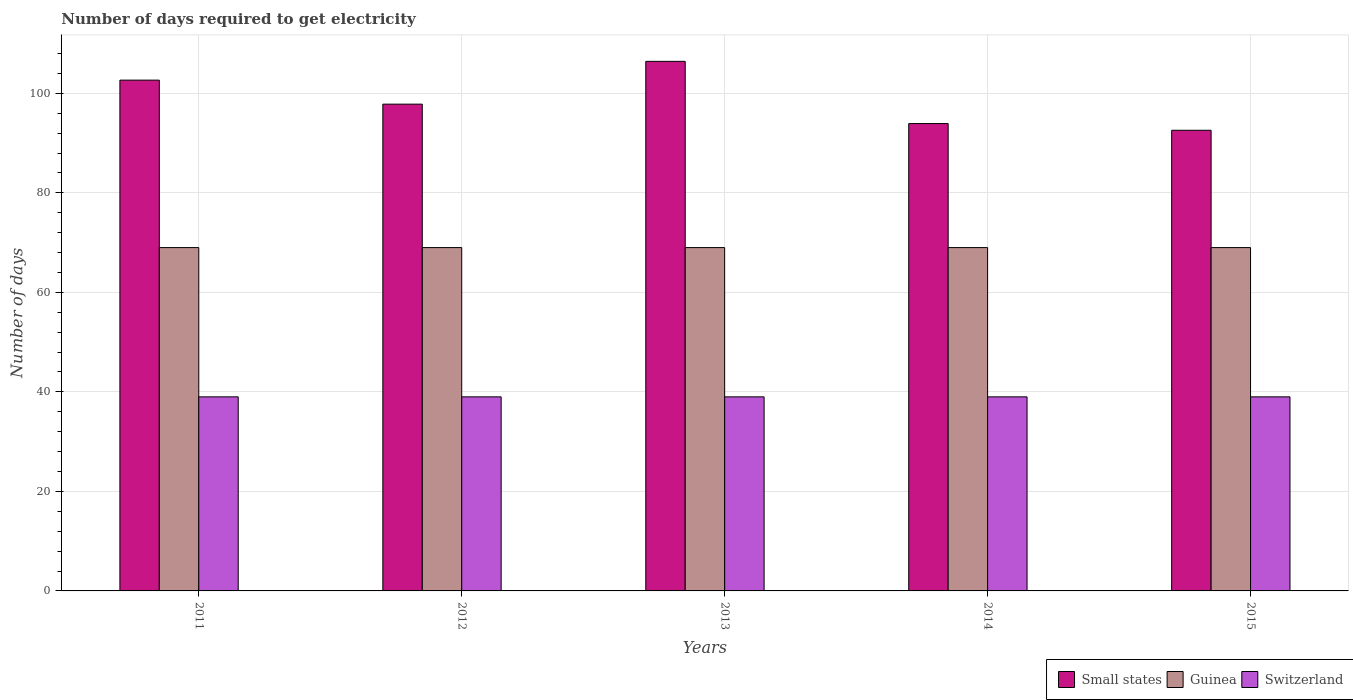How many groups of bars are there?
Your response must be concise. 5. Are the number of bars on each tick of the X-axis equal?
Offer a terse response. Yes. How many bars are there on the 2nd tick from the left?
Offer a very short reply. 3. How many bars are there on the 4th tick from the right?
Give a very brief answer. 3. In how many cases, is the number of bars for a given year not equal to the number of legend labels?
Your response must be concise. 0. What is the number of days required to get electricity in in Switzerland in 2014?
Keep it short and to the point. 39. Across all years, what is the maximum number of days required to get electricity in in Switzerland?
Your response must be concise. 39. Across all years, what is the minimum number of days required to get electricity in in Small states?
Make the answer very short. 92.58. In which year was the number of days required to get electricity in in Guinea minimum?
Make the answer very short. 2011. What is the total number of days required to get electricity in in Switzerland in the graph?
Ensure brevity in your answer.  195. What is the difference between the number of days required to get electricity in in Small states in 2011 and that in 2014?
Provide a short and direct response. 8.73. What is the difference between the number of days required to get electricity in in Small states in 2014 and the number of days required to get electricity in in Switzerland in 2012?
Your response must be concise. 54.92. What is the average number of days required to get electricity in in Small states per year?
Offer a terse response. 98.68. In the year 2014, what is the difference between the number of days required to get electricity in in Guinea and number of days required to get electricity in in Small states?
Your answer should be very brief. -24.92. In how many years, is the number of days required to get electricity in in Small states greater than 44 days?
Give a very brief answer. 5. Is the number of days required to get electricity in in Small states in 2011 less than that in 2015?
Ensure brevity in your answer.  No. What is the difference between the highest and the second highest number of days required to get electricity in in Guinea?
Provide a short and direct response. 0. What is the difference between the highest and the lowest number of days required to get electricity in in Switzerland?
Give a very brief answer. 0. What does the 2nd bar from the left in 2012 represents?
Make the answer very short. Guinea. What does the 2nd bar from the right in 2012 represents?
Offer a terse response. Guinea. Where does the legend appear in the graph?
Ensure brevity in your answer.  Bottom right. How many legend labels are there?
Make the answer very short. 3. How are the legend labels stacked?
Provide a succinct answer. Horizontal. What is the title of the graph?
Ensure brevity in your answer.  Number of days required to get electricity. What is the label or title of the X-axis?
Provide a succinct answer. Years. What is the label or title of the Y-axis?
Ensure brevity in your answer.  Number of days. What is the Number of days of Small states in 2011?
Your answer should be very brief. 102.65. What is the Number of days in Guinea in 2011?
Your answer should be very brief. 69. What is the Number of days of Switzerland in 2011?
Offer a terse response. 39. What is the Number of days of Small states in 2012?
Your answer should be very brief. 97.83. What is the Number of days in Guinea in 2012?
Your answer should be very brief. 69. What is the Number of days in Small states in 2013?
Offer a terse response. 106.42. What is the Number of days of Switzerland in 2013?
Provide a short and direct response. 39. What is the Number of days of Small states in 2014?
Offer a very short reply. 93.92. What is the Number of days of Switzerland in 2014?
Give a very brief answer. 39. What is the Number of days of Small states in 2015?
Your answer should be very brief. 92.58. What is the Number of days in Switzerland in 2015?
Make the answer very short. 39. Across all years, what is the maximum Number of days of Small states?
Ensure brevity in your answer.  106.42. Across all years, what is the maximum Number of days in Switzerland?
Offer a very short reply. 39. Across all years, what is the minimum Number of days in Small states?
Ensure brevity in your answer.  92.58. Across all years, what is the minimum Number of days of Guinea?
Provide a succinct answer. 69. Across all years, what is the minimum Number of days of Switzerland?
Your answer should be compact. 39. What is the total Number of days of Small states in the graph?
Your response must be concise. 493.4. What is the total Number of days of Guinea in the graph?
Offer a very short reply. 345. What is the total Number of days in Switzerland in the graph?
Provide a short and direct response. 195. What is the difference between the Number of days of Small states in 2011 and that in 2012?
Your response must be concise. 4.83. What is the difference between the Number of days in Small states in 2011 and that in 2013?
Give a very brief answer. -3.77. What is the difference between the Number of days in Guinea in 2011 and that in 2013?
Your answer should be very brief. 0. What is the difference between the Number of days in Switzerland in 2011 and that in 2013?
Provide a short and direct response. 0. What is the difference between the Number of days in Small states in 2011 and that in 2014?
Give a very brief answer. 8.72. What is the difference between the Number of days in Small states in 2011 and that in 2015?
Keep it short and to the point. 10.07. What is the difference between the Number of days of Switzerland in 2011 and that in 2015?
Give a very brief answer. 0. What is the difference between the Number of days of Small states in 2012 and that in 2013?
Your answer should be very brief. -8.6. What is the difference between the Number of days of Guinea in 2012 and that in 2013?
Your answer should be very brief. 0. What is the difference between the Number of days of Small states in 2012 and that in 2015?
Offer a terse response. 5.25. What is the difference between the Number of days of Small states in 2013 and that in 2014?
Offer a very short reply. 12.5. What is the difference between the Number of days in Guinea in 2013 and that in 2014?
Make the answer very short. 0. What is the difference between the Number of days of Small states in 2013 and that in 2015?
Provide a succinct answer. 13.85. What is the difference between the Number of days in Guinea in 2013 and that in 2015?
Offer a very short reply. 0. What is the difference between the Number of days in Switzerland in 2013 and that in 2015?
Offer a very short reply. 0. What is the difference between the Number of days in Small states in 2014 and that in 2015?
Keep it short and to the point. 1.35. What is the difference between the Number of days in Switzerland in 2014 and that in 2015?
Provide a short and direct response. 0. What is the difference between the Number of days of Small states in 2011 and the Number of days of Guinea in 2012?
Keep it short and to the point. 33.65. What is the difference between the Number of days in Small states in 2011 and the Number of days in Switzerland in 2012?
Provide a succinct answer. 63.65. What is the difference between the Number of days in Small states in 2011 and the Number of days in Guinea in 2013?
Provide a succinct answer. 33.65. What is the difference between the Number of days in Small states in 2011 and the Number of days in Switzerland in 2013?
Your answer should be very brief. 63.65. What is the difference between the Number of days in Guinea in 2011 and the Number of days in Switzerland in 2013?
Keep it short and to the point. 30. What is the difference between the Number of days of Small states in 2011 and the Number of days of Guinea in 2014?
Your response must be concise. 33.65. What is the difference between the Number of days of Small states in 2011 and the Number of days of Switzerland in 2014?
Provide a short and direct response. 63.65. What is the difference between the Number of days of Small states in 2011 and the Number of days of Guinea in 2015?
Provide a succinct answer. 33.65. What is the difference between the Number of days in Small states in 2011 and the Number of days in Switzerland in 2015?
Provide a succinct answer. 63.65. What is the difference between the Number of days in Guinea in 2011 and the Number of days in Switzerland in 2015?
Offer a terse response. 30. What is the difference between the Number of days in Small states in 2012 and the Number of days in Guinea in 2013?
Provide a succinct answer. 28.82. What is the difference between the Number of days in Small states in 2012 and the Number of days in Switzerland in 2013?
Ensure brevity in your answer.  58.83. What is the difference between the Number of days of Small states in 2012 and the Number of days of Guinea in 2014?
Provide a succinct answer. 28.82. What is the difference between the Number of days of Small states in 2012 and the Number of days of Switzerland in 2014?
Your answer should be very brief. 58.83. What is the difference between the Number of days in Small states in 2012 and the Number of days in Guinea in 2015?
Ensure brevity in your answer.  28.82. What is the difference between the Number of days in Small states in 2012 and the Number of days in Switzerland in 2015?
Ensure brevity in your answer.  58.83. What is the difference between the Number of days of Guinea in 2012 and the Number of days of Switzerland in 2015?
Offer a very short reply. 30. What is the difference between the Number of days in Small states in 2013 and the Number of days in Guinea in 2014?
Offer a very short reply. 37.42. What is the difference between the Number of days in Small states in 2013 and the Number of days in Switzerland in 2014?
Provide a short and direct response. 67.42. What is the difference between the Number of days in Guinea in 2013 and the Number of days in Switzerland in 2014?
Offer a terse response. 30. What is the difference between the Number of days of Small states in 2013 and the Number of days of Guinea in 2015?
Offer a very short reply. 37.42. What is the difference between the Number of days of Small states in 2013 and the Number of days of Switzerland in 2015?
Offer a terse response. 67.42. What is the difference between the Number of days of Guinea in 2013 and the Number of days of Switzerland in 2015?
Offer a terse response. 30. What is the difference between the Number of days of Small states in 2014 and the Number of days of Guinea in 2015?
Keep it short and to the point. 24.93. What is the difference between the Number of days in Small states in 2014 and the Number of days in Switzerland in 2015?
Your answer should be very brief. 54.92. What is the difference between the Number of days of Guinea in 2014 and the Number of days of Switzerland in 2015?
Keep it short and to the point. 30. What is the average Number of days of Small states per year?
Offer a very short reply. 98.68. What is the average Number of days in Switzerland per year?
Offer a terse response. 39. In the year 2011, what is the difference between the Number of days of Small states and Number of days of Guinea?
Make the answer very short. 33.65. In the year 2011, what is the difference between the Number of days of Small states and Number of days of Switzerland?
Provide a short and direct response. 63.65. In the year 2012, what is the difference between the Number of days of Small states and Number of days of Guinea?
Ensure brevity in your answer.  28.82. In the year 2012, what is the difference between the Number of days in Small states and Number of days in Switzerland?
Offer a terse response. 58.83. In the year 2013, what is the difference between the Number of days in Small states and Number of days in Guinea?
Offer a terse response. 37.42. In the year 2013, what is the difference between the Number of days in Small states and Number of days in Switzerland?
Offer a very short reply. 67.42. In the year 2014, what is the difference between the Number of days in Small states and Number of days in Guinea?
Ensure brevity in your answer.  24.93. In the year 2014, what is the difference between the Number of days of Small states and Number of days of Switzerland?
Ensure brevity in your answer.  54.92. In the year 2015, what is the difference between the Number of days in Small states and Number of days in Guinea?
Give a very brief answer. 23.57. In the year 2015, what is the difference between the Number of days of Small states and Number of days of Switzerland?
Your answer should be compact. 53.58. What is the ratio of the Number of days of Small states in 2011 to that in 2012?
Give a very brief answer. 1.05. What is the ratio of the Number of days in Guinea in 2011 to that in 2012?
Your response must be concise. 1. What is the ratio of the Number of days in Switzerland in 2011 to that in 2012?
Your response must be concise. 1. What is the ratio of the Number of days of Small states in 2011 to that in 2013?
Provide a short and direct response. 0.96. What is the ratio of the Number of days of Guinea in 2011 to that in 2013?
Keep it short and to the point. 1. What is the ratio of the Number of days of Small states in 2011 to that in 2014?
Provide a succinct answer. 1.09. What is the ratio of the Number of days of Guinea in 2011 to that in 2014?
Give a very brief answer. 1. What is the ratio of the Number of days in Switzerland in 2011 to that in 2014?
Your answer should be compact. 1. What is the ratio of the Number of days in Small states in 2011 to that in 2015?
Your response must be concise. 1.11. What is the ratio of the Number of days of Guinea in 2011 to that in 2015?
Give a very brief answer. 1. What is the ratio of the Number of days of Small states in 2012 to that in 2013?
Your answer should be compact. 0.92. What is the ratio of the Number of days in Guinea in 2012 to that in 2013?
Give a very brief answer. 1. What is the ratio of the Number of days in Switzerland in 2012 to that in 2013?
Your answer should be very brief. 1. What is the ratio of the Number of days of Small states in 2012 to that in 2014?
Your answer should be very brief. 1.04. What is the ratio of the Number of days of Guinea in 2012 to that in 2014?
Offer a very short reply. 1. What is the ratio of the Number of days of Small states in 2012 to that in 2015?
Make the answer very short. 1.06. What is the ratio of the Number of days in Guinea in 2012 to that in 2015?
Keep it short and to the point. 1. What is the ratio of the Number of days of Switzerland in 2012 to that in 2015?
Your response must be concise. 1. What is the ratio of the Number of days of Small states in 2013 to that in 2014?
Your answer should be compact. 1.13. What is the ratio of the Number of days of Guinea in 2013 to that in 2014?
Make the answer very short. 1. What is the ratio of the Number of days in Switzerland in 2013 to that in 2014?
Provide a short and direct response. 1. What is the ratio of the Number of days of Small states in 2013 to that in 2015?
Give a very brief answer. 1.15. What is the ratio of the Number of days in Switzerland in 2013 to that in 2015?
Your response must be concise. 1. What is the ratio of the Number of days of Small states in 2014 to that in 2015?
Ensure brevity in your answer.  1.01. What is the difference between the highest and the second highest Number of days in Small states?
Offer a very short reply. 3.77. What is the difference between the highest and the lowest Number of days of Small states?
Your answer should be very brief. 13.85. 